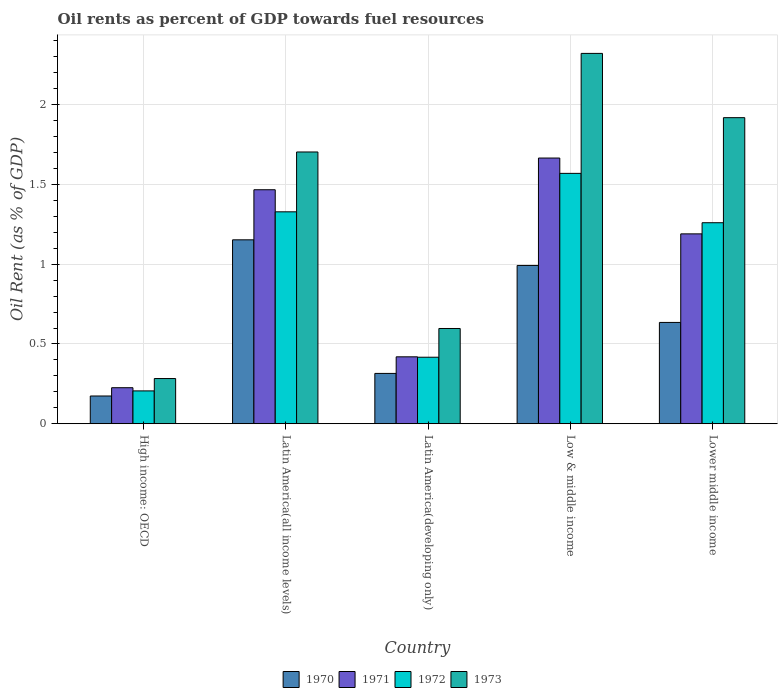How many different coloured bars are there?
Provide a short and direct response. 4. How many groups of bars are there?
Provide a short and direct response. 5. Are the number of bars per tick equal to the number of legend labels?
Provide a succinct answer. Yes. How many bars are there on the 1st tick from the left?
Make the answer very short. 4. How many bars are there on the 1st tick from the right?
Ensure brevity in your answer.  4. What is the label of the 1st group of bars from the left?
Provide a succinct answer. High income: OECD. In how many cases, is the number of bars for a given country not equal to the number of legend labels?
Your answer should be compact. 0. What is the oil rent in 1973 in Lower middle income?
Give a very brief answer. 1.92. Across all countries, what is the maximum oil rent in 1971?
Your answer should be compact. 1.67. Across all countries, what is the minimum oil rent in 1973?
Make the answer very short. 0.28. In which country was the oil rent in 1970 minimum?
Your response must be concise. High income: OECD. What is the total oil rent in 1973 in the graph?
Provide a short and direct response. 6.82. What is the difference between the oil rent in 1972 in Latin America(developing only) and that in Lower middle income?
Make the answer very short. -0.84. What is the difference between the oil rent in 1972 in Lower middle income and the oil rent in 1970 in Latin America(developing only)?
Offer a terse response. 0.94. What is the average oil rent in 1971 per country?
Your answer should be very brief. 0.99. What is the difference between the oil rent of/in 1973 and oil rent of/in 1972 in High income: OECD?
Your answer should be very brief. 0.08. In how many countries, is the oil rent in 1972 greater than 1.9 %?
Offer a terse response. 0. What is the ratio of the oil rent in 1973 in Latin America(developing only) to that in Lower middle income?
Give a very brief answer. 0.31. Is the difference between the oil rent in 1973 in High income: OECD and Low & middle income greater than the difference between the oil rent in 1972 in High income: OECD and Low & middle income?
Make the answer very short. No. What is the difference between the highest and the second highest oil rent in 1972?
Provide a short and direct response. 0.31. What is the difference between the highest and the lowest oil rent in 1971?
Your answer should be very brief. 1.44. Is it the case that in every country, the sum of the oil rent in 1971 and oil rent in 1972 is greater than the sum of oil rent in 1970 and oil rent in 1973?
Your response must be concise. No. What does the 1st bar from the left in High income: OECD represents?
Your answer should be very brief. 1970. What does the 2nd bar from the right in Latin America(developing only) represents?
Offer a very short reply. 1972. How many bars are there?
Your answer should be very brief. 20. What is the difference between two consecutive major ticks on the Y-axis?
Your response must be concise. 0.5. Are the values on the major ticks of Y-axis written in scientific E-notation?
Your response must be concise. No. Does the graph contain grids?
Your answer should be very brief. Yes. Where does the legend appear in the graph?
Ensure brevity in your answer.  Bottom center. How are the legend labels stacked?
Provide a succinct answer. Horizontal. What is the title of the graph?
Provide a short and direct response. Oil rents as percent of GDP towards fuel resources. Does "2007" appear as one of the legend labels in the graph?
Make the answer very short. No. What is the label or title of the Y-axis?
Provide a succinct answer. Oil Rent (as % of GDP). What is the Oil Rent (as % of GDP) of 1970 in High income: OECD?
Give a very brief answer. 0.17. What is the Oil Rent (as % of GDP) in 1971 in High income: OECD?
Ensure brevity in your answer.  0.23. What is the Oil Rent (as % of GDP) in 1972 in High income: OECD?
Your answer should be very brief. 0.21. What is the Oil Rent (as % of GDP) of 1973 in High income: OECD?
Offer a terse response. 0.28. What is the Oil Rent (as % of GDP) in 1970 in Latin America(all income levels)?
Keep it short and to the point. 1.15. What is the Oil Rent (as % of GDP) in 1971 in Latin America(all income levels)?
Your answer should be compact. 1.47. What is the Oil Rent (as % of GDP) in 1972 in Latin America(all income levels)?
Give a very brief answer. 1.33. What is the Oil Rent (as % of GDP) of 1973 in Latin America(all income levels)?
Offer a very short reply. 1.7. What is the Oil Rent (as % of GDP) in 1970 in Latin America(developing only)?
Ensure brevity in your answer.  0.32. What is the Oil Rent (as % of GDP) of 1971 in Latin America(developing only)?
Your answer should be compact. 0.42. What is the Oil Rent (as % of GDP) of 1972 in Latin America(developing only)?
Make the answer very short. 0.42. What is the Oil Rent (as % of GDP) in 1973 in Latin America(developing only)?
Your response must be concise. 0.6. What is the Oil Rent (as % of GDP) in 1970 in Low & middle income?
Keep it short and to the point. 0.99. What is the Oil Rent (as % of GDP) in 1971 in Low & middle income?
Provide a short and direct response. 1.67. What is the Oil Rent (as % of GDP) in 1972 in Low & middle income?
Your answer should be very brief. 1.57. What is the Oil Rent (as % of GDP) in 1973 in Low & middle income?
Provide a succinct answer. 2.32. What is the Oil Rent (as % of GDP) in 1970 in Lower middle income?
Give a very brief answer. 0.63. What is the Oil Rent (as % of GDP) of 1971 in Lower middle income?
Provide a succinct answer. 1.19. What is the Oil Rent (as % of GDP) in 1972 in Lower middle income?
Offer a very short reply. 1.26. What is the Oil Rent (as % of GDP) of 1973 in Lower middle income?
Provide a short and direct response. 1.92. Across all countries, what is the maximum Oil Rent (as % of GDP) of 1970?
Provide a short and direct response. 1.15. Across all countries, what is the maximum Oil Rent (as % of GDP) of 1971?
Keep it short and to the point. 1.67. Across all countries, what is the maximum Oil Rent (as % of GDP) of 1972?
Give a very brief answer. 1.57. Across all countries, what is the maximum Oil Rent (as % of GDP) of 1973?
Give a very brief answer. 2.32. Across all countries, what is the minimum Oil Rent (as % of GDP) in 1970?
Ensure brevity in your answer.  0.17. Across all countries, what is the minimum Oil Rent (as % of GDP) in 1971?
Your answer should be very brief. 0.23. Across all countries, what is the minimum Oil Rent (as % of GDP) of 1972?
Give a very brief answer. 0.21. Across all countries, what is the minimum Oil Rent (as % of GDP) in 1973?
Ensure brevity in your answer.  0.28. What is the total Oil Rent (as % of GDP) of 1970 in the graph?
Provide a succinct answer. 3.27. What is the total Oil Rent (as % of GDP) of 1971 in the graph?
Provide a succinct answer. 4.97. What is the total Oil Rent (as % of GDP) in 1972 in the graph?
Offer a terse response. 4.78. What is the total Oil Rent (as % of GDP) in 1973 in the graph?
Your response must be concise. 6.82. What is the difference between the Oil Rent (as % of GDP) in 1970 in High income: OECD and that in Latin America(all income levels)?
Provide a succinct answer. -0.98. What is the difference between the Oil Rent (as % of GDP) in 1971 in High income: OECD and that in Latin America(all income levels)?
Provide a succinct answer. -1.24. What is the difference between the Oil Rent (as % of GDP) of 1972 in High income: OECD and that in Latin America(all income levels)?
Make the answer very short. -1.12. What is the difference between the Oil Rent (as % of GDP) of 1973 in High income: OECD and that in Latin America(all income levels)?
Provide a short and direct response. -1.42. What is the difference between the Oil Rent (as % of GDP) in 1970 in High income: OECD and that in Latin America(developing only)?
Offer a very short reply. -0.14. What is the difference between the Oil Rent (as % of GDP) of 1971 in High income: OECD and that in Latin America(developing only)?
Provide a succinct answer. -0.19. What is the difference between the Oil Rent (as % of GDP) in 1972 in High income: OECD and that in Latin America(developing only)?
Offer a terse response. -0.21. What is the difference between the Oil Rent (as % of GDP) in 1973 in High income: OECD and that in Latin America(developing only)?
Provide a succinct answer. -0.31. What is the difference between the Oil Rent (as % of GDP) in 1970 in High income: OECD and that in Low & middle income?
Your response must be concise. -0.82. What is the difference between the Oil Rent (as % of GDP) in 1971 in High income: OECD and that in Low & middle income?
Your response must be concise. -1.44. What is the difference between the Oil Rent (as % of GDP) of 1972 in High income: OECD and that in Low & middle income?
Provide a short and direct response. -1.36. What is the difference between the Oil Rent (as % of GDP) in 1973 in High income: OECD and that in Low & middle income?
Ensure brevity in your answer.  -2.04. What is the difference between the Oil Rent (as % of GDP) of 1970 in High income: OECD and that in Lower middle income?
Keep it short and to the point. -0.46. What is the difference between the Oil Rent (as % of GDP) of 1971 in High income: OECD and that in Lower middle income?
Your response must be concise. -0.96. What is the difference between the Oil Rent (as % of GDP) of 1972 in High income: OECD and that in Lower middle income?
Offer a very short reply. -1.05. What is the difference between the Oil Rent (as % of GDP) of 1973 in High income: OECD and that in Lower middle income?
Offer a terse response. -1.64. What is the difference between the Oil Rent (as % of GDP) of 1970 in Latin America(all income levels) and that in Latin America(developing only)?
Offer a very short reply. 0.84. What is the difference between the Oil Rent (as % of GDP) in 1971 in Latin America(all income levels) and that in Latin America(developing only)?
Give a very brief answer. 1.05. What is the difference between the Oil Rent (as % of GDP) of 1972 in Latin America(all income levels) and that in Latin America(developing only)?
Offer a very short reply. 0.91. What is the difference between the Oil Rent (as % of GDP) in 1973 in Latin America(all income levels) and that in Latin America(developing only)?
Your response must be concise. 1.11. What is the difference between the Oil Rent (as % of GDP) of 1970 in Latin America(all income levels) and that in Low & middle income?
Keep it short and to the point. 0.16. What is the difference between the Oil Rent (as % of GDP) of 1971 in Latin America(all income levels) and that in Low & middle income?
Provide a succinct answer. -0.2. What is the difference between the Oil Rent (as % of GDP) of 1972 in Latin America(all income levels) and that in Low & middle income?
Provide a succinct answer. -0.24. What is the difference between the Oil Rent (as % of GDP) of 1973 in Latin America(all income levels) and that in Low & middle income?
Your answer should be compact. -0.62. What is the difference between the Oil Rent (as % of GDP) of 1970 in Latin America(all income levels) and that in Lower middle income?
Offer a very short reply. 0.52. What is the difference between the Oil Rent (as % of GDP) of 1971 in Latin America(all income levels) and that in Lower middle income?
Offer a very short reply. 0.28. What is the difference between the Oil Rent (as % of GDP) in 1972 in Latin America(all income levels) and that in Lower middle income?
Your answer should be very brief. 0.07. What is the difference between the Oil Rent (as % of GDP) of 1973 in Latin America(all income levels) and that in Lower middle income?
Keep it short and to the point. -0.21. What is the difference between the Oil Rent (as % of GDP) of 1970 in Latin America(developing only) and that in Low & middle income?
Make the answer very short. -0.68. What is the difference between the Oil Rent (as % of GDP) of 1971 in Latin America(developing only) and that in Low & middle income?
Your answer should be compact. -1.25. What is the difference between the Oil Rent (as % of GDP) of 1972 in Latin America(developing only) and that in Low & middle income?
Your answer should be very brief. -1.15. What is the difference between the Oil Rent (as % of GDP) of 1973 in Latin America(developing only) and that in Low & middle income?
Offer a very short reply. -1.72. What is the difference between the Oil Rent (as % of GDP) of 1970 in Latin America(developing only) and that in Lower middle income?
Offer a very short reply. -0.32. What is the difference between the Oil Rent (as % of GDP) of 1971 in Latin America(developing only) and that in Lower middle income?
Your answer should be compact. -0.77. What is the difference between the Oil Rent (as % of GDP) in 1972 in Latin America(developing only) and that in Lower middle income?
Ensure brevity in your answer.  -0.84. What is the difference between the Oil Rent (as % of GDP) in 1973 in Latin America(developing only) and that in Lower middle income?
Your answer should be very brief. -1.32. What is the difference between the Oil Rent (as % of GDP) in 1970 in Low & middle income and that in Lower middle income?
Give a very brief answer. 0.36. What is the difference between the Oil Rent (as % of GDP) of 1971 in Low & middle income and that in Lower middle income?
Your response must be concise. 0.48. What is the difference between the Oil Rent (as % of GDP) in 1972 in Low & middle income and that in Lower middle income?
Provide a succinct answer. 0.31. What is the difference between the Oil Rent (as % of GDP) in 1973 in Low & middle income and that in Lower middle income?
Your response must be concise. 0.4. What is the difference between the Oil Rent (as % of GDP) in 1970 in High income: OECD and the Oil Rent (as % of GDP) in 1971 in Latin America(all income levels)?
Give a very brief answer. -1.29. What is the difference between the Oil Rent (as % of GDP) of 1970 in High income: OECD and the Oil Rent (as % of GDP) of 1972 in Latin America(all income levels)?
Provide a short and direct response. -1.15. What is the difference between the Oil Rent (as % of GDP) of 1970 in High income: OECD and the Oil Rent (as % of GDP) of 1973 in Latin America(all income levels)?
Offer a terse response. -1.53. What is the difference between the Oil Rent (as % of GDP) in 1971 in High income: OECD and the Oil Rent (as % of GDP) in 1972 in Latin America(all income levels)?
Give a very brief answer. -1.1. What is the difference between the Oil Rent (as % of GDP) of 1971 in High income: OECD and the Oil Rent (as % of GDP) of 1973 in Latin America(all income levels)?
Ensure brevity in your answer.  -1.48. What is the difference between the Oil Rent (as % of GDP) in 1972 in High income: OECD and the Oil Rent (as % of GDP) in 1973 in Latin America(all income levels)?
Make the answer very short. -1.5. What is the difference between the Oil Rent (as % of GDP) of 1970 in High income: OECD and the Oil Rent (as % of GDP) of 1971 in Latin America(developing only)?
Your answer should be very brief. -0.25. What is the difference between the Oil Rent (as % of GDP) in 1970 in High income: OECD and the Oil Rent (as % of GDP) in 1972 in Latin America(developing only)?
Provide a short and direct response. -0.24. What is the difference between the Oil Rent (as % of GDP) in 1970 in High income: OECD and the Oil Rent (as % of GDP) in 1973 in Latin America(developing only)?
Ensure brevity in your answer.  -0.42. What is the difference between the Oil Rent (as % of GDP) in 1971 in High income: OECD and the Oil Rent (as % of GDP) in 1972 in Latin America(developing only)?
Keep it short and to the point. -0.19. What is the difference between the Oil Rent (as % of GDP) of 1971 in High income: OECD and the Oil Rent (as % of GDP) of 1973 in Latin America(developing only)?
Offer a very short reply. -0.37. What is the difference between the Oil Rent (as % of GDP) of 1972 in High income: OECD and the Oil Rent (as % of GDP) of 1973 in Latin America(developing only)?
Make the answer very short. -0.39. What is the difference between the Oil Rent (as % of GDP) in 1970 in High income: OECD and the Oil Rent (as % of GDP) in 1971 in Low & middle income?
Your answer should be very brief. -1.49. What is the difference between the Oil Rent (as % of GDP) of 1970 in High income: OECD and the Oil Rent (as % of GDP) of 1972 in Low & middle income?
Make the answer very short. -1.4. What is the difference between the Oil Rent (as % of GDP) in 1970 in High income: OECD and the Oil Rent (as % of GDP) in 1973 in Low & middle income?
Provide a short and direct response. -2.15. What is the difference between the Oil Rent (as % of GDP) of 1971 in High income: OECD and the Oil Rent (as % of GDP) of 1972 in Low & middle income?
Keep it short and to the point. -1.34. What is the difference between the Oil Rent (as % of GDP) in 1971 in High income: OECD and the Oil Rent (as % of GDP) in 1973 in Low & middle income?
Offer a very short reply. -2.1. What is the difference between the Oil Rent (as % of GDP) of 1972 in High income: OECD and the Oil Rent (as % of GDP) of 1973 in Low & middle income?
Keep it short and to the point. -2.12. What is the difference between the Oil Rent (as % of GDP) in 1970 in High income: OECD and the Oil Rent (as % of GDP) in 1971 in Lower middle income?
Provide a succinct answer. -1.02. What is the difference between the Oil Rent (as % of GDP) of 1970 in High income: OECD and the Oil Rent (as % of GDP) of 1972 in Lower middle income?
Provide a succinct answer. -1.09. What is the difference between the Oil Rent (as % of GDP) of 1970 in High income: OECD and the Oil Rent (as % of GDP) of 1973 in Lower middle income?
Give a very brief answer. -1.74. What is the difference between the Oil Rent (as % of GDP) of 1971 in High income: OECD and the Oil Rent (as % of GDP) of 1972 in Lower middle income?
Your response must be concise. -1.03. What is the difference between the Oil Rent (as % of GDP) in 1971 in High income: OECD and the Oil Rent (as % of GDP) in 1973 in Lower middle income?
Offer a very short reply. -1.69. What is the difference between the Oil Rent (as % of GDP) in 1972 in High income: OECD and the Oil Rent (as % of GDP) in 1973 in Lower middle income?
Provide a short and direct response. -1.71. What is the difference between the Oil Rent (as % of GDP) in 1970 in Latin America(all income levels) and the Oil Rent (as % of GDP) in 1971 in Latin America(developing only)?
Offer a terse response. 0.73. What is the difference between the Oil Rent (as % of GDP) of 1970 in Latin America(all income levels) and the Oil Rent (as % of GDP) of 1972 in Latin America(developing only)?
Provide a succinct answer. 0.74. What is the difference between the Oil Rent (as % of GDP) in 1970 in Latin America(all income levels) and the Oil Rent (as % of GDP) in 1973 in Latin America(developing only)?
Your response must be concise. 0.56. What is the difference between the Oil Rent (as % of GDP) of 1971 in Latin America(all income levels) and the Oil Rent (as % of GDP) of 1972 in Latin America(developing only)?
Provide a succinct answer. 1.05. What is the difference between the Oil Rent (as % of GDP) of 1971 in Latin America(all income levels) and the Oil Rent (as % of GDP) of 1973 in Latin America(developing only)?
Offer a very short reply. 0.87. What is the difference between the Oil Rent (as % of GDP) in 1972 in Latin America(all income levels) and the Oil Rent (as % of GDP) in 1973 in Latin America(developing only)?
Make the answer very short. 0.73. What is the difference between the Oil Rent (as % of GDP) in 1970 in Latin America(all income levels) and the Oil Rent (as % of GDP) in 1971 in Low & middle income?
Offer a very short reply. -0.51. What is the difference between the Oil Rent (as % of GDP) of 1970 in Latin America(all income levels) and the Oil Rent (as % of GDP) of 1972 in Low & middle income?
Make the answer very short. -0.42. What is the difference between the Oil Rent (as % of GDP) of 1970 in Latin America(all income levels) and the Oil Rent (as % of GDP) of 1973 in Low & middle income?
Your response must be concise. -1.17. What is the difference between the Oil Rent (as % of GDP) in 1971 in Latin America(all income levels) and the Oil Rent (as % of GDP) in 1972 in Low & middle income?
Make the answer very short. -0.1. What is the difference between the Oil Rent (as % of GDP) of 1971 in Latin America(all income levels) and the Oil Rent (as % of GDP) of 1973 in Low & middle income?
Provide a short and direct response. -0.85. What is the difference between the Oil Rent (as % of GDP) of 1972 in Latin America(all income levels) and the Oil Rent (as % of GDP) of 1973 in Low & middle income?
Your response must be concise. -0.99. What is the difference between the Oil Rent (as % of GDP) in 1970 in Latin America(all income levels) and the Oil Rent (as % of GDP) in 1971 in Lower middle income?
Your response must be concise. -0.04. What is the difference between the Oil Rent (as % of GDP) in 1970 in Latin America(all income levels) and the Oil Rent (as % of GDP) in 1972 in Lower middle income?
Offer a terse response. -0.11. What is the difference between the Oil Rent (as % of GDP) of 1970 in Latin America(all income levels) and the Oil Rent (as % of GDP) of 1973 in Lower middle income?
Provide a short and direct response. -0.77. What is the difference between the Oil Rent (as % of GDP) in 1971 in Latin America(all income levels) and the Oil Rent (as % of GDP) in 1972 in Lower middle income?
Offer a terse response. 0.21. What is the difference between the Oil Rent (as % of GDP) of 1971 in Latin America(all income levels) and the Oil Rent (as % of GDP) of 1973 in Lower middle income?
Offer a terse response. -0.45. What is the difference between the Oil Rent (as % of GDP) of 1972 in Latin America(all income levels) and the Oil Rent (as % of GDP) of 1973 in Lower middle income?
Offer a very short reply. -0.59. What is the difference between the Oil Rent (as % of GDP) of 1970 in Latin America(developing only) and the Oil Rent (as % of GDP) of 1971 in Low & middle income?
Ensure brevity in your answer.  -1.35. What is the difference between the Oil Rent (as % of GDP) in 1970 in Latin America(developing only) and the Oil Rent (as % of GDP) in 1972 in Low & middle income?
Your answer should be compact. -1.25. What is the difference between the Oil Rent (as % of GDP) in 1970 in Latin America(developing only) and the Oil Rent (as % of GDP) in 1973 in Low & middle income?
Make the answer very short. -2.01. What is the difference between the Oil Rent (as % of GDP) of 1971 in Latin America(developing only) and the Oil Rent (as % of GDP) of 1972 in Low & middle income?
Offer a terse response. -1.15. What is the difference between the Oil Rent (as % of GDP) in 1971 in Latin America(developing only) and the Oil Rent (as % of GDP) in 1973 in Low & middle income?
Give a very brief answer. -1.9. What is the difference between the Oil Rent (as % of GDP) of 1972 in Latin America(developing only) and the Oil Rent (as % of GDP) of 1973 in Low & middle income?
Your response must be concise. -1.9. What is the difference between the Oil Rent (as % of GDP) of 1970 in Latin America(developing only) and the Oil Rent (as % of GDP) of 1971 in Lower middle income?
Keep it short and to the point. -0.87. What is the difference between the Oil Rent (as % of GDP) in 1970 in Latin America(developing only) and the Oil Rent (as % of GDP) in 1972 in Lower middle income?
Provide a short and direct response. -0.94. What is the difference between the Oil Rent (as % of GDP) of 1970 in Latin America(developing only) and the Oil Rent (as % of GDP) of 1973 in Lower middle income?
Provide a short and direct response. -1.6. What is the difference between the Oil Rent (as % of GDP) of 1971 in Latin America(developing only) and the Oil Rent (as % of GDP) of 1972 in Lower middle income?
Offer a very short reply. -0.84. What is the difference between the Oil Rent (as % of GDP) of 1971 in Latin America(developing only) and the Oil Rent (as % of GDP) of 1973 in Lower middle income?
Ensure brevity in your answer.  -1.5. What is the difference between the Oil Rent (as % of GDP) in 1972 in Latin America(developing only) and the Oil Rent (as % of GDP) in 1973 in Lower middle income?
Your answer should be very brief. -1.5. What is the difference between the Oil Rent (as % of GDP) of 1970 in Low & middle income and the Oil Rent (as % of GDP) of 1971 in Lower middle income?
Keep it short and to the point. -0.2. What is the difference between the Oil Rent (as % of GDP) in 1970 in Low & middle income and the Oil Rent (as % of GDP) in 1972 in Lower middle income?
Keep it short and to the point. -0.27. What is the difference between the Oil Rent (as % of GDP) in 1970 in Low & middle income and the Oil Rent (as % of GDP) in 1973 in Lower middle income?
Offer a terse response. -0.93. What is the difference between the Oil Rent (as % of GDP) of 1971 in Low & middle income and the Oil Rent (as % of GDP) of 1972 in Lower middle income?
Provide a succinct answer. 0.41. What is the difference between the Oil Rent (as % of GDP) of 1971 in Low & middle income and the Oil Rent (as % of GDP) of 1973 in Lower middle income?
Provide a succinct answer. -0.25. What is the difference between the Oil Rent (as % of GDP) in 1972 in Low & middle income and the Oil Rent (as % of GDP) in 1973 in Lower middle income?
Make the answer very short. -0.35. What is the average Oil Rent (as % of GDP) of 1970 per country?
Provide a succinct answer. 0.65. What is the average Oil Rent (as % of GDP) of 1971 per country?
Offer a terse response. 0.99. What is the average Oil Rent (as % of GDP) of 1972 per country?
Offer a terse response. 0.96. What is the average Oil Rent (as % of GDP) of 1973 per country?
Offer a terse response. 1.36. What is the difference between the Oil Rent (as % of GDP) of 1970 and Oil Rent (as % of GDP) of 1971 in High income: OECD?
Offer a terse response. -0.05. What is the difference between the Oil Rent (as % of GDP) in 1970 and Oil Rent (as % of GDP) in 1972 in High income: OECD?
Offer a very short reply. -0.03. What is the difference between the Oil Rent (as % of GDP) of 1970 and Oil Rent (as % of GDP) of 1973 in High income: OECD?
Your answer should be compact. -0.11. What is the difference between the Oil Rent (as % of GDP) of 1971 and Oil Rent (as % of GDP) of 1973 in High income: OECD?
Offer a terse response. -0.06. What is the difference between the Oil Rent (as % of GDP) in 1972 and Oil Rent (as % of GDP) in 1973 in High income: OECD?
Your answer should be very brief. -0.08. What is the difference between the Oil Rent (as % of GDP) in 1970 and Oil Rent (as % of GDP) in 1971 in Latin America(all income levels)?
Your response must be concise. -0.31. What is the difference between the Oil Rent (as % of GDP) in 1970 and Oil Rent (as % of GDP) in 1972 in Latin America(all income levels)?
Keep it short and to the point. -0.18. What is the difference between the Oil Rent (as % of GDP) in 1970 and Oil Rent (as % of GDP) in 1973 in Latin America(all income levels)?
Offer a very short reply. -0.55. What is the difference between the Oil Rent (as % of GDP) in 1971 and Oil Rent (as % of GDP) in 1972 in Latin America(all income levels)?
Ensure brevity in your answer.  0.14. What is the difference between the Oil Rent (as % of GDP) in 1971 and Oil Rent (as % of GDP) in 1973 in Latin America(all income levels)?
Your answer should be very brief. -0.24. What is the difference between the Oil Rent (as % of GDP) in 1972 and Oil Rent (as % of GDP) in 1973 in Latin America(all income levels)?
Make the answer very short. -0.38. What is the difference between the Oil Rent (as % of GDP) in 1970 and Oil Rent (as % of GDP) in 1971 in Latin America(developing only)?
Provide a short and direct response. -0.1. What is the difference between the Oil Rent (as % of GDP) in 1970 and Oil Rent (as % of GDP) in 1972 in Latin America(developing only)?
Provide a short and direct response. -0.1. What is the difference between the Oil Rent (as % of GDP) of 1970 and Oil Rent (as % of GDP) of 1973 in Latin America(developing only)?
Ensure brevity in your answer.  -0.28. What is the difference between the Oil Rent (as % of GDP) in 1971 and Oil Rent (as % of GDP) in 1972 in Latin America(developing only)?
Provide a succinct answer. 0. What is the difference between the Oil Rent (as % of GDP) in 1971 and Oil Rent (as % of GDP) in 1973 in Latin America(developing only)?
Give a very brief answer. -0.18. What is the difference between the Oil Rent (as % of GDP) in 1972 and Oil Rent (as % of GDP) in 1973 in Latin America(developing only)?
Provide a short and direct response. -0.18. What is the difference between the Oil Rent (as % of GDP) of 1970 and Oil Rent (as % of GDP) of 1971 in Low & middle income?
Keep it short and to the point. -0.67. What is the difference between the Oil Rent (as % of GDP) of 1970 and Oil Rent (as % of GDP) of 1972 in Low & middle income?
Offer a terse response. -0.58. What is the difference between the Oil Rent (as % of GDP) in 1970 and Oil Rent (as % of GDP) in 1973 in Low & middle income?
Your response must be concise. -1.33. What is the difference between the Oil Rent (as % of GDP) in 1971 and Oil Rent (as % of GDP) in 1972 in Low & middle income?
Offer a very short reply. 0.1. What is the difference between the Oil Rent (as % of GDP) of 1971 and Oil Rent (as % of GDP) of 1973 in Low & middle income?
Make the answer very short. -0.66. What is the difference between the Oil Rent (as % of GDP) of 1972 and Oil Rent (as % of GDP) of 1973 in Low & middle income?
Offer a very short reply. -0.75. What is the difference between the Oil Rent (as % of GDP) of 1970 and Oil Rent (as % of GDP) of 1971 in Lower middle income?
Your answer should be very brief. -0.56. What is the difference between the Oil Rent (as % of GDP) in 1970 and Oil Rent (as % of GDP) in 1972 in Lower middle income?
Provide a succinct answer. -0.62. What is the difference between the Oil Rent (as % of GDP) of 1970 and Oil Rent (as % of GDP) of 1973 in Lower middle income?
Offer a terse response. -1.28. What is the difference between the Oil Rent (as % of GDP) in 1971 and Oil Rent (as % of GDP) in 1972 in Lower middle income?
Provide a succinct answer. -0.07. What is the difference between the Oil Rent (as % of GDP) in 1971 and Oil Rent (as % of GDP) in 1973 in Lower middle income?
Your answer should be compact. -0.73. What is the difference between the Oil Rent (as % of GDP) of 1972 and Oil Rent (as % of GDP) of 1973 in Lower middle income?
Your answer should be very brief. -0.66. What is the ratio of the Oil Rent (as % of GDP) of 1970 in High income: OECD to that in Latin America(all income levels)?
Offer a terse response. 0.15. What is the ratio of the Oil Rent (as % of GDP) of 1971 in High income: OECD to that in Latin America(all income levels)?
Provide a succinct answer. 0.15. What is the ratio of the Oil Rent (as % of GDP) of 1972 in High income: OECD to that in Latin America(all income levels)?
Provide a succinct answer. 0.15. What is the ratio of the Oil Rent (as % of GDP) in 1973 in High income: OECD to that in Latin America(all income levels)?
Provide a succinct answer. 0.17. What is the ratio of the Oil Rent (as % of GDP) of 1970 in High income: OECD to that in Latin America(developing only)?
Give a very brief answer. 0.55. What is the ratio of the Oil Rent (as % of GDP) of 1971 in High income: OECD to that in Latin America(developing only)?
Provide a short and direct response. 0.54. What is the ratio of the Oil Rent (as % of GDP) of 1972 in High income: OECD to that in Latin America(developing only)?
Offer a terse response. 0.49. What is the ratio of the Oil Rent (as % of GDP) of 1973 in High income: OECD to that in Latin America(developing only)?
Offer a terse response. 0.47. What is the ratio of the Oil Rent (as % of GDP) in 1970 in High income: OECD to that in Low & middle income?
Provide a succinct answer. 0.18. What is the ratio of the Oil Rent (as % of GDP) of 1971 in High income: OECD to that in Low & middle income?
Offer a terse response. 0.14. What is the ratio of the Oil Rent (as % of GDP) of 1972 in High income: OECD to that in Low & middle income?
Offer a terse response. 0.13. What is the ratio of the Oil Rent (as % of GDP) in 1973 in High income: OECD to that in Low & middle income?
Your answer should be compact. 0.12. What is the ratio of the Oil Rent (as % of GDP) of 1970 in High income: OECD to that in Lower middle income?
Ensure brevity in your answer.  0.27. What is the ratio of the Oil Rent (as % of GDP) in 1971 in High income: OECD to that in Lower middle income?
Your answer should be very brief. 0.19. What is the ratio of the Oil Rent (as % of GDP) in 1972 in High income: OECD to that in Lower middle income?
Your response must be concise. 0.16. What is the ratio of the Oil Rent (as % of GDP) in 1973 in High income: OECD to that in Lower middle income?
Your answer should be very brief. 0.15. What is the ratio of the Oil Rent (as % of GDP) of 1970 in Latin America(all income levels) to that in Latin America(developing only)?
Keep it short and to the point. 3.65. What is the ratio of the Oil Rent (as % of GDP) in 1971 in Latin America(all income levels) to that in Latin America(developing only)?
Your answer should be very brief. 3.5. What is the ratio of the Oil Rent (as % of GDP) in 1972 in Latin America(all income levels) to that in Latin America(developing only)?
Provide a succinct answer. 3.19. What is the ratio of the Oil Rent (as % of GDP) of 1973 in Latin America(all income levels) to that in Latin America(developing only)?
Provide a short and direct response. 2.85. What is the ratio of the Oil Rent (as % of GDP) of 1970 in Latin America(all income levels) to that in Low & middle income?
Ensure brevity in your answer.  1.16. What is the ratio of the Oil Rent (as % of GDP) in 1971 in Latin America(all income levels) to that in Low & middle income?
Provide a succinct answer. 0.88. What is the ratio of the Oil Rent (as % of GDP) in 1972 in Latin America(all income levels) to that in Low & middle income?
Offer a very short reply. 0.85. What is the ratio of the Oil Rent (as % of GDP) in 1973 in Latin America(all income levels) to that in Low & middle income?
Give a very brief answer. 0.73. What is the ratio of the Oil Rent (as % of GDP) in 1970 in Latin America(all income levels) to that in Lower middle income?
Your response must be concise. 1.82. What is the ratio of the Oil Rent (as % of GDP) of 1971 in Latin America(all income levels) to that in Lower middle income?
Your response must be concise. 1.23. What is the ratio of the Oil Rent (as % of GDP) of 1972 in Latin America(all income levels) to that in Lower middle income?
Keep it short and to the point. 1.05. What is the ratio of the Oil Rent (as % of GDP) in 1973 in Latin America(all income levels) to that in Lower middle income?
Provide a succinct answer. 0.89. What is the ratio of the Oil Rent (as % of GDP) of 1970 in Latin America(developing only) to that in Low & middle income?
Your response must be concise. 0.32. What is the ratio of the Oil Rent (as % of GDP) in 1971 in Latin America(developing only) to that in Low & middle income?
Provide a succinct answer. 0.25. What is the ratio of the Oil Rent (as % of GDP) of 1972 in Latin America(developing only) to that in Low & middle income?
Give a very brief answer. 0.27. What is the ratio of the Oil Rent (as % of GDP) of 1973 in Latin America(developing only) to that in Low & middle income?
Give a very brief answer. 0.26. What is the ratio of the Oil Rent (as % of GDP) in 1970 in Latin America(developing only) to that in Lower middle income?
Your answer should be very brief. 0.5. What is the ratio of the Oil Rent (as % of GDP) of 1971 in Latin America(developing only) to that in Lower middle income?
Ensure brevity in your answer.  0.35. What is the ratio of the Oil Rent (as % of GDP) in 1972 in Latin America(developing only) to that in Lower middle income?
Your response must be concise. 0.33. What is the ratio of the Oil Rent (as % of GDP) in 1973 in Latin America(developing only) to that in Lower middle income?
Give a very brief answer. 0.31. What is the ratio of the Oil Rent (as % of GDP) of 1970 in Low & middle income to that in Lower middle income?
Give a very brief answer. 1.56. What is the ratio of the Oil Rent (as % of GDP) of 1971 in Low & middle income to that in Lower middle income?
Make the answer very short. 1.4. What is the ratio of the Oil Rent (as % of GDP) in 1972 in Low & middle income to that in Lower middle income?
Keep it short and to the point. 1.25. What is the ratio of the Oil Rent (as % of GDP) in 1973 in Low & middle income to that in Lower middle income?
Give a very brief answer. 1.21. What is the difference between the highest and the second highest Oil Rent (as % of GDP) of 1970?
Provide a succinct answer. 0.16. What is the difference between the highest and the second highest Oil Rent (as % of GDP) in 1971?
Your answer should be very brief. 0.2. What is the difference between the highest and the second highest Oil Rent (as % of GDP) in 1972?
Your response must be concise. 0.24. What is the difference between the highest and the second highest Oil Rent (as % of GDP) in 1973?
Your response must be concise. 0.4. What is the difference between the highest and the lowest Oil Rent (as % of GDP) in 1970?
Provide a short and direct response. 0.98. What is the difference between the highest and the lowest Oil Rent (as % of GDP) in 1971?
Offer a terse response. 1.44. What is the difference between the highest and the lowest Oil Rent (as % of GDP) in 1972?
Ensure brevity in your answer.  1.36. What is the difference between the highest and the lowest Oil Rent (as % of GDP) in 1973?
Make the answer very short. 2.04. 